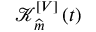Convert formula to latex. <formula><loc_0><loc_0><loc_500><loc_500>\mathcal { K } _ { \widehat { m } } ^ { [ V ] } \left ( t \right )</formula> 